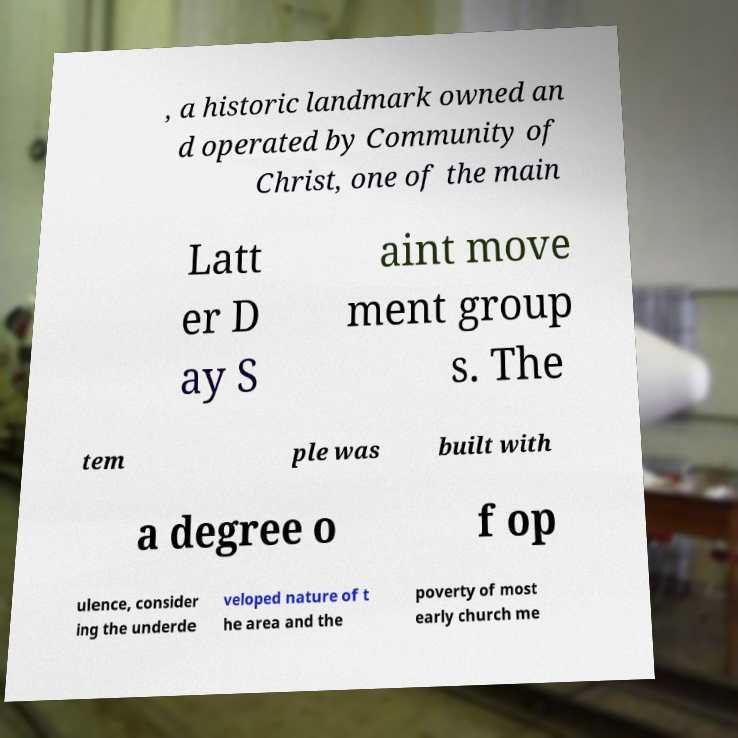Can you accurately transcribe the text from the provided image for me? , a historic landmark owned an d operated by Community of Christ, one of the main Latt er D ay S aint move ment group s. The tem ple was built with a degree o f op ulence, consider ing the underde veloped nature of t he area and the poverty of most early church me 